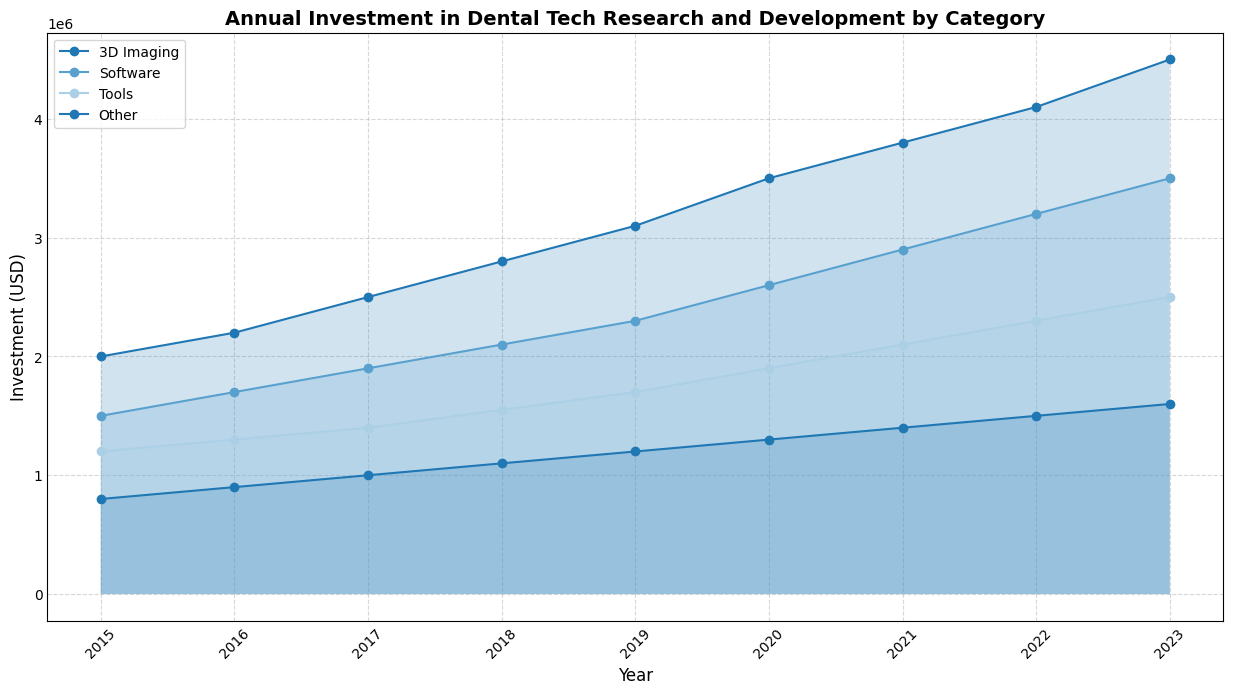What was the investment in 3D Imaging in 2018? Looking at the year 2018 on the x-axis and the corresponding value for 3D Imaging on the y-axis, the investment can be seen.
Answer: 2800000 Which category had the highest investment in 2023? By checking the values for each category in 2023, it's observed that 3D Imaging has the highest value.
Answer: 3D Imaging How did the investment in Software change from 2015 to 2023? Subtract the investment in Software in 2015 from the investment in 2023 to find the change over the period. The difference is 3500000 - 1500000.
Answer: 2000000 Which year saw the highest investment in Tools? By comparing the values for Tools across all the years, 2023 has the highest value.
Answer: 2023 Was the trend of investment in Other category increasing, decreasing, or fluctuating between 2015 and 2023? Observing the values for the Other category from 2015 to 2023, it increases steadily.
Answer: Increasing Compare the investment in 3D Imaging and Tools in 2019. The values for 3D Imaging and Tools in 2019 are 3100000 and 1700000 respectively; 3D Imaging is higher.
Answer: 3D Imaging What is the overall trend in the investment for Software over the years? Observing the line for Software from 2015 to 2023, the investment is consistently increasing.
Answer: Increasing Find the average annual investment in Other from 2015 to 2023. Sum the values from 2015 to 2023 and divide by the number of years. The sum is 800000 + 900000 + 1000000 + 1100000 + 1200000 + 1300000 + 1400000 + 1500000 + 1600000 = 10700000. The average is 10700000/9.
Answer: 1188888.89 What was the investment difference between 3D Imaging and Software in 2021? Subtract the investment in Software from 3D Imaging in 2021: 3800000 - 2900000.
Answer: 900000 Between which years did the investment in Tools see the largest increase? Calculate the annual increase and find the maximum: 
2016: 1300000-1200000=100000, 
2017: 1400000-1300000=100000, 
2018: 1550000-1400000=150000, 
2019: 1700000-1550000=150000, 
2020: 1900000-1700000=200000, 
2021: 2100000-1900000=200000, 
2022: 2300000-2100000=200000, 
2023: 2500000-2300000=200000. 
The largest increase was from 2019 to 2020, 2020 to 2021, 2021 to 2022, and 2022 to 2023, all with 200000.
Answer: 2019-2020, 2020-2021, 2021-2022, 2022-2023 